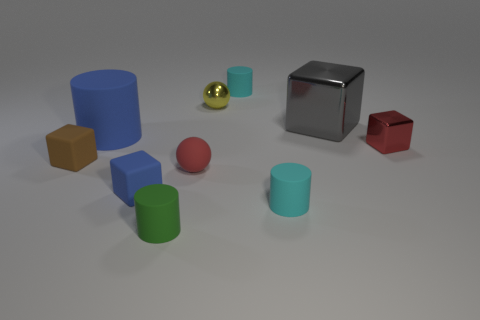Subtract all cylinders. How many objects are left? 6 Subtract all small red matte objects. Subtract all shiny spheres. How many objects are left? 8 Add 3 red objects. How many red objects are left? 5 Add 9 red cylinders. How many red cylinders exist? 9 Subtract 0 brown cylinders. How many objects are left? 10 